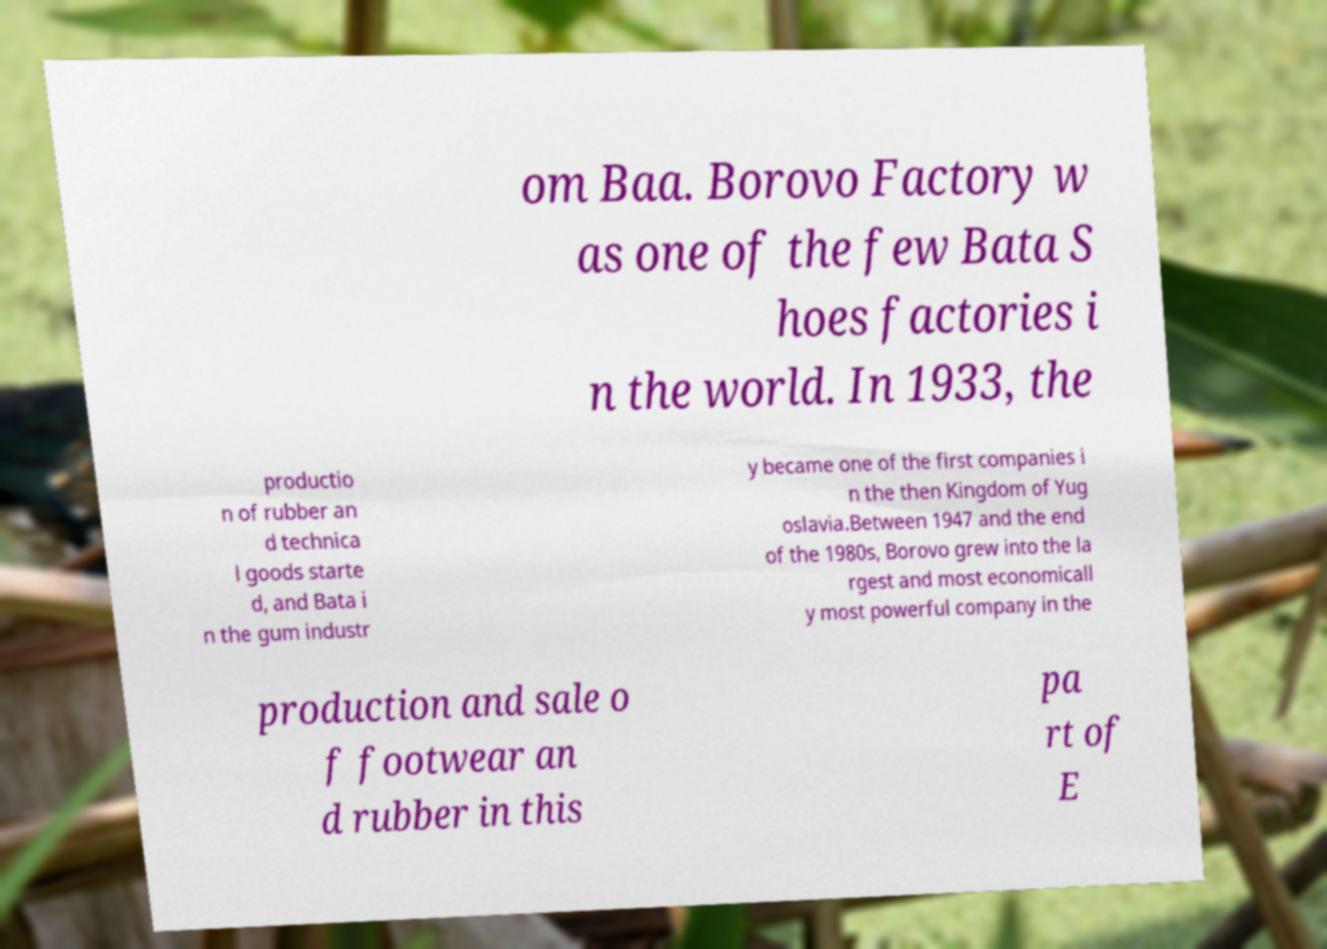Can you accurately transcribe the text from the provided image for me? om Baa. Borovo Factory w as one of the few Bata S hoes factories i n the world. In 1933, the productio n of rubber an d technica l goods starte d, and Bata i n the gum industr y became one of the first companies i n the then Kingdom of Yug oslavia.Between 1947 and the end of the 1980s, Borovo grew into the la rgest and most economicall y most powerful company in the production and sale o f footwear an d rubber in this pa rt of E 